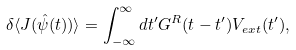<formula> <loc_0><loc_0><loc_500><loc_500>\delta \langle J ( \hat { \psi } ( t ) ) \rangle = \int _ { - \infty } ^ { \infty } d t ^ { \prime } G ^ { R } ( t - t ^ { \prime } ) V _ { e x t } ( t ^ { \prime } \/ ) ,</formula> 